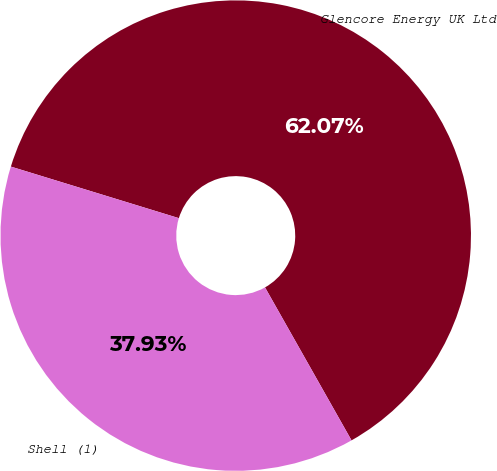Convert chart to OTSL. <chart><loc_0><loc_0><loc_500><loc_500><pie_chart><fcel>Glencore Energy UK Ltd<fcel>Shell (1)<nl><fcel>62.07%<fcel>37.93%<nl></chart> 